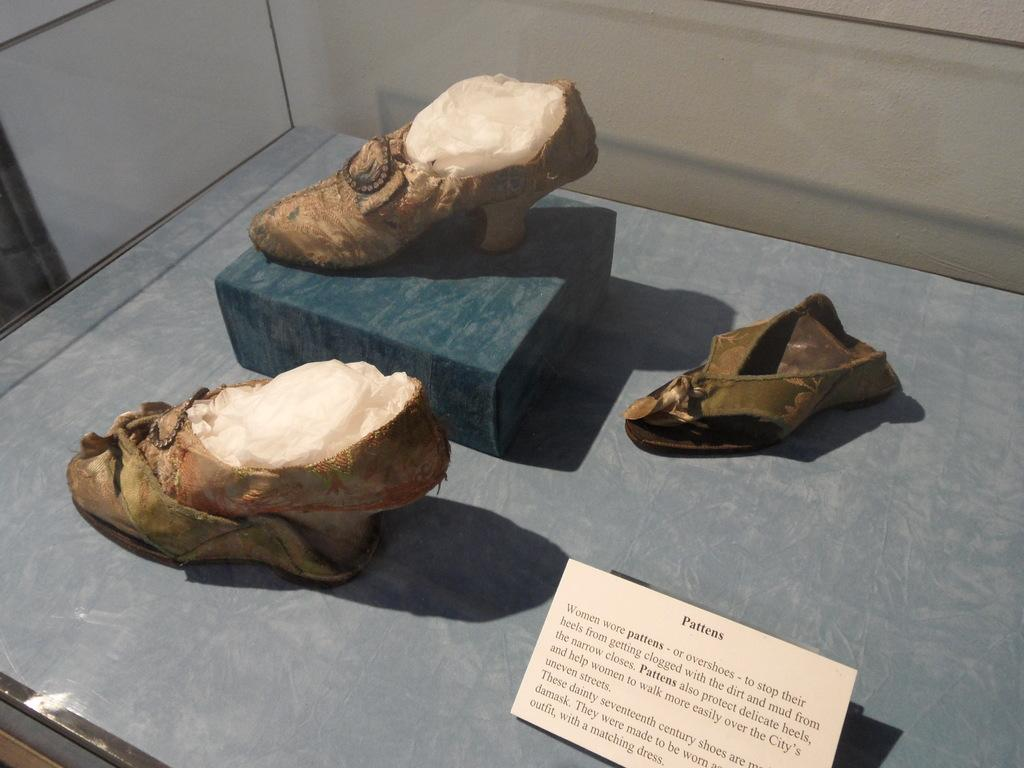What objects are present in the image? There are shoes and a card in the image. Where are the shoes located? The shoes are on a surface in the image. What can be found on the card? The card has text on it. Are there any feet inside the shoes in the image? There is no information about feet inside the shoes in the image. 